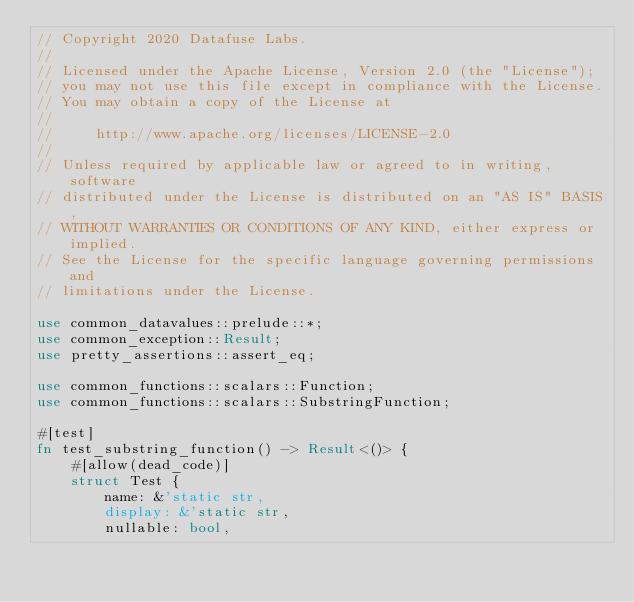Convert code to text. <code><loc_0><loc_0><loc_500><loc_500><_Rust_>// Copyright 2020 Datafuse Labs.
//
// Licensed under the Apache License, Version 2.0 (the "License");
// you may not use this file except in compliance with the License.
// You may obtain a copy of the License at
//
//     http://www.apache.org/licenses/LICENSE-2.0
//
// Unless required by applicable law or agreed to in writing, software
// distributed under the License is distributed on an "AS IS" BASIS,
// WITHOUT WARRANTIES OR CONDITIONS OF ANY KIND, either express or implied.
// See the License for the specific language governing permissions and
// limitations under the License.

use common_datavalues::prelude::*;
use common_exception::Result;
use pretty_assertions::assert_eq;

use common_functions::scalars::Function;
use common_functions::scalars::SubstringFunction;

#[test]
fn test_substring_function() -> Result<()> {
    #[allow(dead_code)]
    struct Test {
        name: &'static str,
        display: &'static str,
        nullable: bool,</code> 